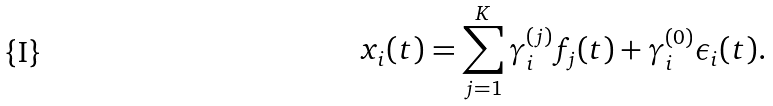<formula> <loc_0><loc_0><loc_500><loc_500>x _ { i } ( t ) = \sum _ { j = 1 } ^ { K } \gamma _ { i } ^ { ( j ) } f _ { j } ( t ) + \gamma _ { i } ^ { ( 0 ) } \epsilon _ { i } ( t ) .</formula> 